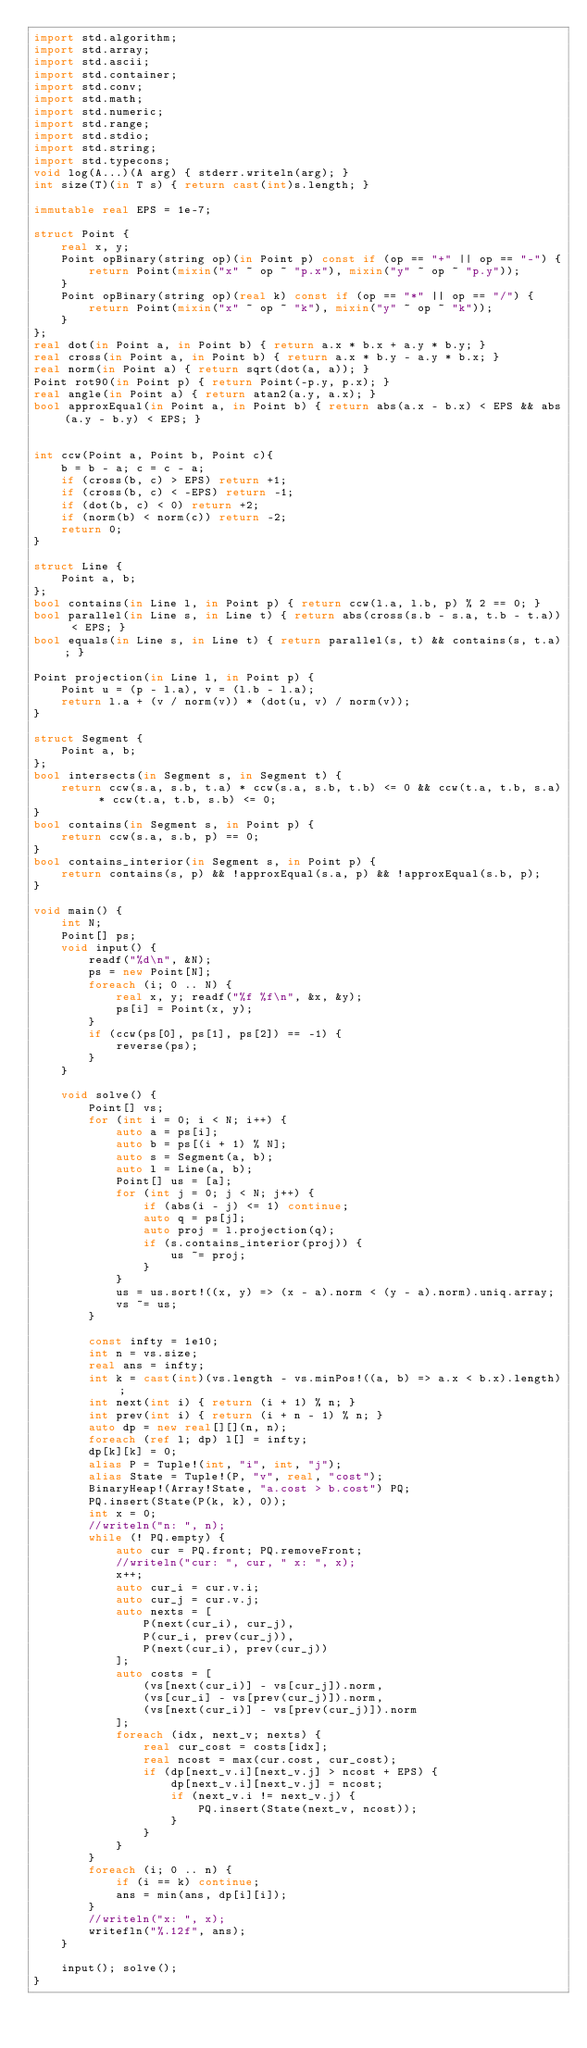Convert code to text. <code><loc_0><loc_0><loc_500><loc_500><_D_>import std.algorithm;
import std.array;
import std.ascii;
import std.container;
import std.conv;
import std.math;
import std.numeric;
import std.range;
import std.stdio;
import std.string;
import std.typecons;
void log(A...)(A arg) { stderr.writeln(arg); }
int size(T)(in T s) { return cast(int)s.length; }

immutable real EPS = 1e-7;

struct Point {
    real x, y;
    Point opBinary(string op)(in Point p) const if (op == "+" || op == "-") {
        return Point(mixin("x" ~ op ~ "p.x"), mixin("y" ~ op ~ "p.y"));
    }
    Point opBinary(string op)(real k) const if (op == "*" || op == "/") {
        return Point(mixin("x" ~ op ~ "k"), mixin("y" ~ op ~ "k"));
    }
};
real dot(in Point a, in Point b) { return a.x * b.x + a.y * b.y; }
real cross(in Point a, in Point b) { return a.x * b.y - a.y * b.x; }
real norm(in Point a) { return sqrt(dot(a, a)); }
Point rot90(in Point p) { return Point(-p.y, p.x); }
real angle(in Point a) { return atan2(a.y, a.x); }
bool approxEqual(in Point a, in Point b) { return abs(a.x - b.x) < EPS && abs(a.y - b.y) < EPS; }


int ccw(Point a, Point b, Point c){
    b = b - a; c = c - a;                                          
    if (cross(b, c) > EPS) return +1;     
    if (cross(b, c) < -EPS) return -1;    
    if (dot(b, c) < 0) return +2;         
    if (norm(b) < norm(c)) return -2;     
    return 0;                             
}

struct Line {
    Point a, b;
};
bool contains(in Line l, in Point p) { return ccw(l.a, l.b, p) % 2 == 0; }
bool parallel(in Line s, in Line t) { return abs(cross(s.b - s.a, t.b - t.a)) < EPS; }
bool equals(in Line s, in Line t) { return parallel(s, t) && contains(s, t.a); }

Point projection(in Line l, in Point p) {
    Point u = (p - l.a), v = (l.b - l.a);
    return l.a + (v / norm(v)) * (dot(u, v) / norm(v));
}

struct Segment {
    Point a, b;
};
bool intersects(in Segment s, in Segment t) {
    return ccw(s.a, s.b, t.a) * ccw(s.a, s.b, t.b) <= 0 && ccw(t.a, t.b, s.a) * ccw(t.a, t.b, s.b) <= 0;
}
bool contains(in Segment s, in Point p) {
    return ccw(s.a, s.b, p) == 0;
}
bool contains_interior(in Segment s, in Point p) {
    return contains(s, p) && !approxEqual(s.a, p) && !approxEqual(s.b, p);
}

void main() {
    int N;
    Point[] ps;
    void input() {
        readf("%d\n", &N);
        ps = new Point[N];
        foreach (i; 0 .. N) {
            real x, y; readf("%f %f\n", &x, &y);
            ps[i] = Point(x, y);
        }
        if (ccw(ps[0], ps[1], ps[2]) == -1) {
            reverse(ps);
        }
    }

    void solve() {
        Point[] vs;
        for (int i = 0; i < N; i++) {
            auto a = ps[i];
            auto b = ps[(i + 1) % N];
            auto s = Segment(a, b);
            auto l = Line(a, b);
            Point[] us = [a];
            for (int j = 0; j < N; j++) {
                if (abs(i - j) <= 1) continue;
                auto q = ps[j];
                auto proj = l.projection(q);
                if (s.contains_interior(proj)) {
                    us ~= proj;
                }
            }
            us = us.sort!((x, y) => (x - a).norm < (y - a).norm).uniq.array;
            vs ~= us;
        }

        const infty = 1e10;
        int n = vs.size;
        real ans = infty;
        int k = cast(int)(vs.length - vs.minPos!((a, b) => a.x < b.x).length);
        int next(int i) { return (i + 1) % n; }
        int prev(int i) { return (i + n - 1) % n; }
        auto dp = new real[][](n, n);
        foreach (ref l; dp) l[] = infty;
        dp[k][k] = 0;
        alias P = Tuple!(int, "i", int, "j");
        alias State = Tuple!(P, "v", real, "cost");
        BinaryHeap!(Array!State, "a.cost > b.cost") PQ;
        PQ.insert(State(P(k, k), 0));
        int x = 0;
        //writeln("n: ", n);
        while (! PQ.empty) {
            auto cur = PQ.front; PQ.removeFront;
            //writeln("cur: ", cur, " x: ", x);
            x++;
            auto cur_i = cur.v.i;
            auto cur_j = cur.v.j;
            auto nexts = [
                P(next(cur_i), cur_j),
                P(cur_i, prev(cur_j)),
                P(next(cur_i), prev(cur_j))
            ];
            auto costs = [
                (vs[next(cur_i)] - vs[cur_j]).norm,
                (vs[cur_i] - vs[prev(cur_j)]).norm,
                (vs[next(cur_i)] - vs[prev(cur_j)]).norm
            ];
            foreach (idx, next_v; nexts) {
                real cur_cost = costs[idx];
                real ncost = max(cur.cost, cur_cost);
                if (dp[next_v.i][next_v.j] > ncost + EPS) {
                    dp[next_v.i][next_v.j] = ncost;
                    if (next_v.i != next_v.j) {
                        PQ.insert(State(next_v, ncost));
                    }
                }
            }
        }
        foreach (i; 0 .. n) {
            if (i == k) continue;
            ans = min(ans, dp[i][i]);
        }
        //writeln("x: ", x);
        writefln("%.12f", ans);
    }

    input(); solve();
}</code> 